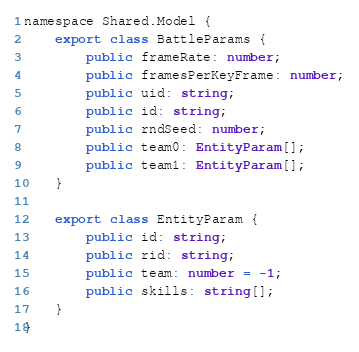Convert code to text. <code><loc_0><loc_0><loc_500><loc_500><_TypeScript_>namespace Shared.Model {
	export class BattleParams {
		public frameRate: number;
		public framesPerKeyFrame: number;
		public uid: string;
		public id: string;
		public rndSeed: number;
		public team0: EntityParam[];
		public team1: EntityParam[];
	}

	export class EntityParam {
		public id: string;
		public rid: string;
		public team: number = -1;
		public skills: string[];
	}
}</code> 